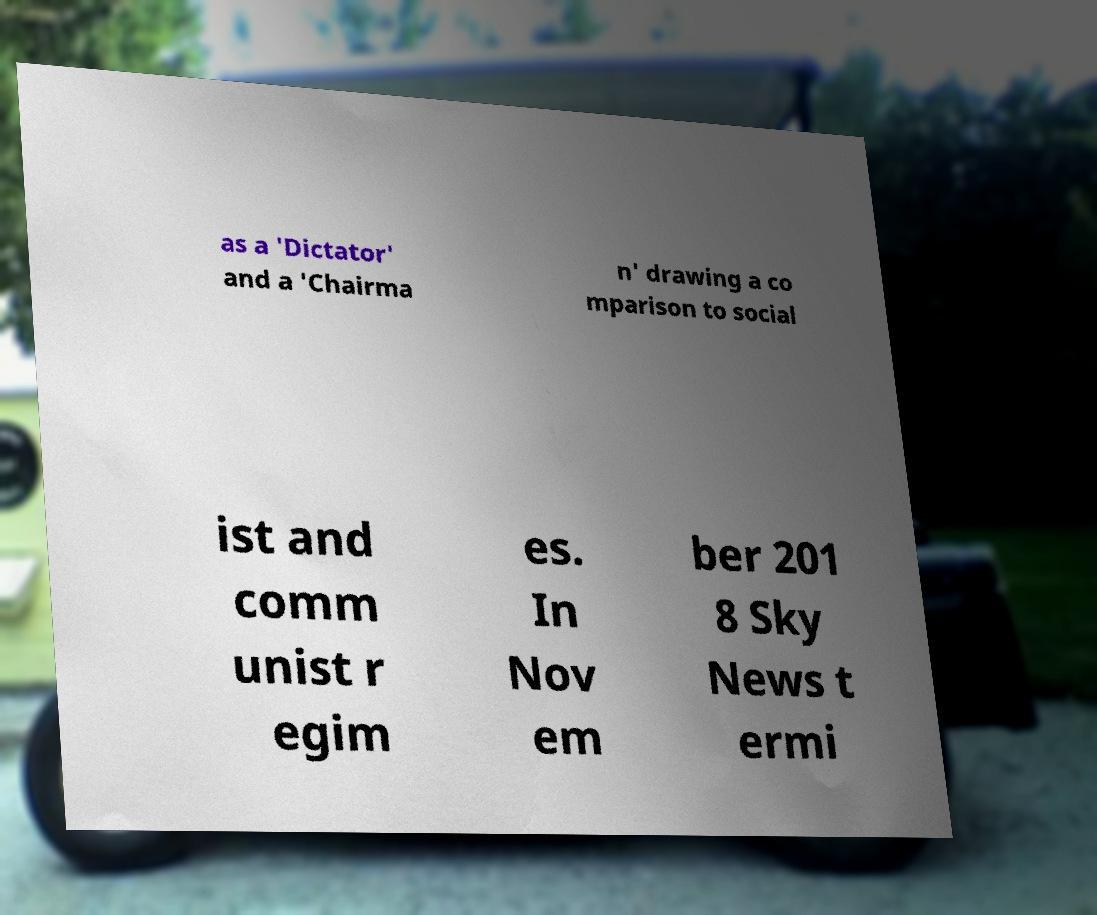There's text embedded in this image that I need extracted. Can you transcribe it verbatim? as a 'Dictator' and a 'Chairma n' drawing a co mparison to social ist and comm unist r egim es. In Nov em ber 201 8 Sky News t ermi 